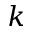<formula> <loc_0><loc_0><loc_500><loc_500>k</formula> 